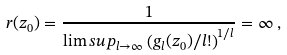Convert formula to latex. <formula><loc_0><loc_0><loc_500><loc_500>r ( z _ { 0 } ) = \frac { 1 } { \lim s u p _ { l \to \infty } \left ( g _ { l } ( z _ { 0 } ) / l ! \right ) ^ { 1 / l } } = \infty \, ,</formula> 